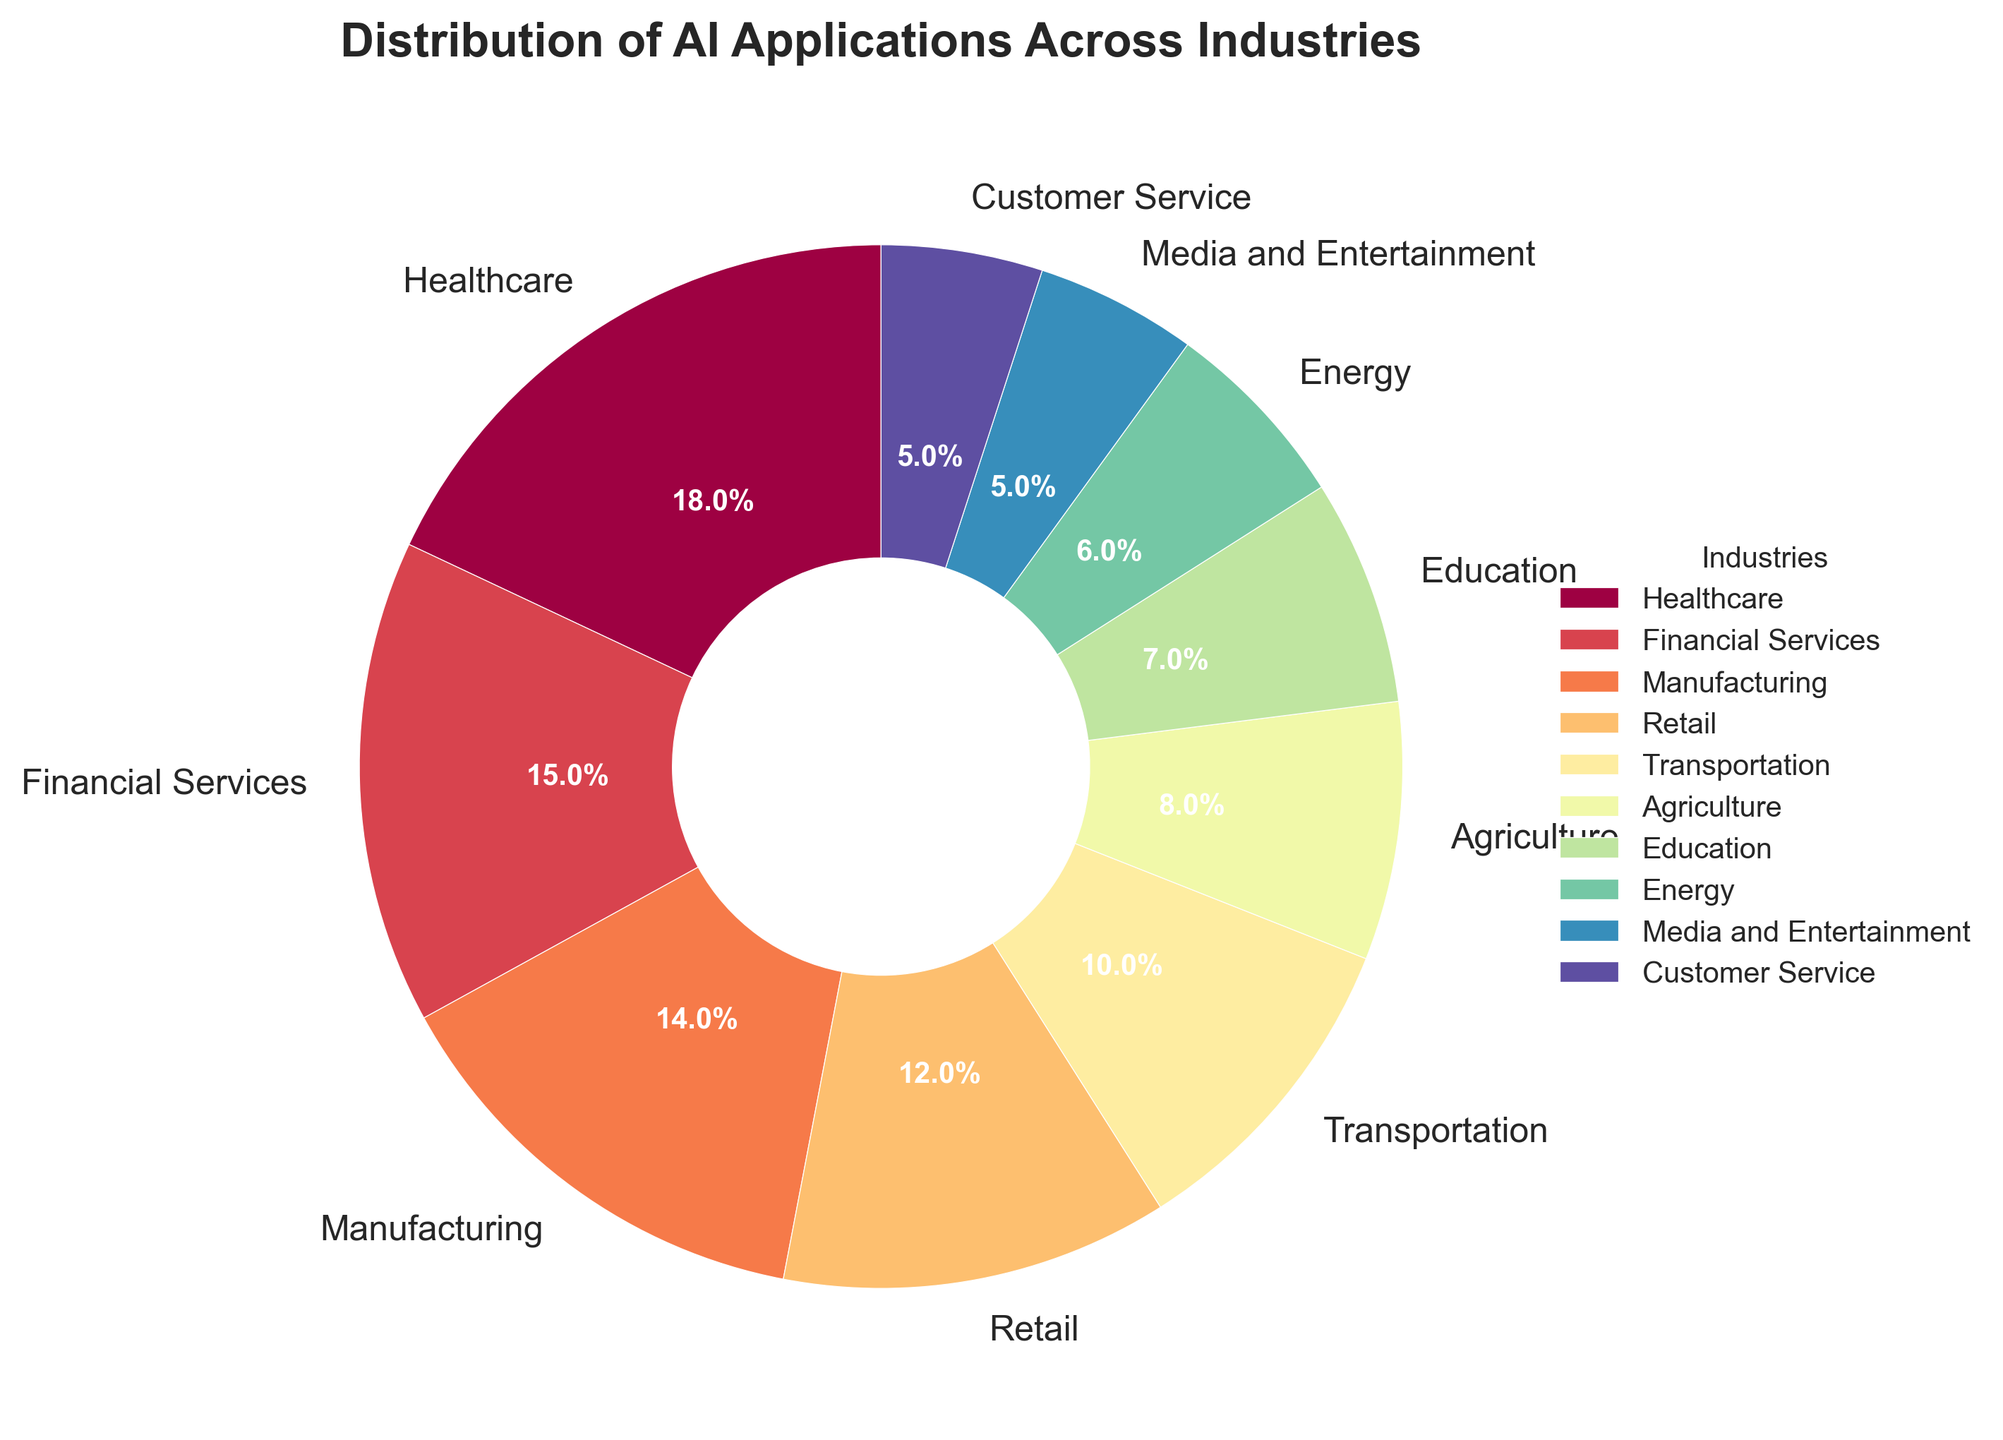What's the largest industry by percentage for AI applications? By looking at the pie chart, we can identify the industry with the biggest wedge. The 'Healthcare' segment is the largest at 18%.
Answer: Healthcare Which industry has a higher percentage of AI applications, Agriculture or Retail? Comparing the sizes of the wedges labeled 'Agriculture' and 'Retail', Retail at 12% is higher than Agriculture at 8%.
Answer: Retail What is the cumulative percentage for the top three industries? The top three industries are Healthcare (18%), Financial Services (15%), and Manufacturing (14%). Summing these percentages gives 18 + 15 + 14 = 47%.
Answer: 47% What is the difference in percentage between Transportation and Media and Entertainment? Transportation is at 10% while Media and Entertainment is at 5%. The difference is 10 - 5 = 5%.
Answer: 5% Which industries have equal percentages of AI applications? Both Media and Entertainment and Customer Service sectors show the same percentage of 5%.
Answer: Media and Entertainment, Customer Service Is the percentage of AI applications in Education more than in Energy? The Education wedge is at 7% whereas Energy is at 6%. 7% is greater than 6%, so yes, Education has a higher percentage than Energy.
Answer: Yes What is the combined percentage of AI applications in Customer Service and Media and Entertainment? Both industries show a percentage of 5%. Adding these together gives 5 + 5 = 10%.
Answer: 10% Which industry has the smallest percentage of AI applications? Observing the smallest wedge, we find that both Media and Entertainment and Customer Service are tied at the lowest percentage of 5%.
Answer: Media and Entertainment, Customer Service What is the ratio of the percentage of AI applications in Healthcare to Transportation? The percentage for Healthcare is 18%, and for Transportation, it is 10%. The ratio is 18:10, which simplifies to 9:5.
Answer: 9:5 